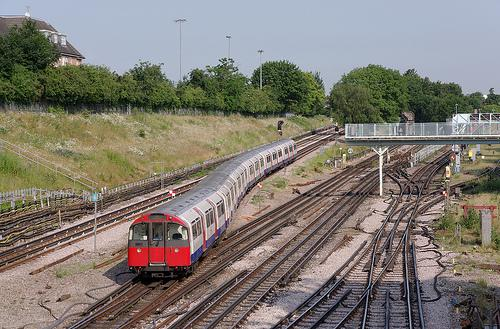Question: what is it on?
Choices:
A. The road.
B. Rail tracks.
C. The gravel.
D. The sidewalk.
Answer with the letter. Answer: B Question: who is present?
Choices:
A. A man.
B. Nobody.
C. A woman.
D. A child.
Answer with the letter. Answer: B Question: where was this photo taken?
Choices:
A. Near animals.
B. Street.
C. On the train tracks.
D. School yard.
Answer with the letter. Answer: C 